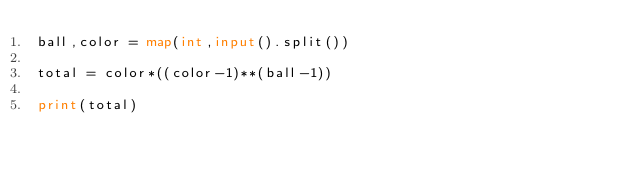<code> <loc_0><loc_0><loc_500><loc_500><_Python_>ball,color = map(int,input().split())

total = color*((color-1)**(ball-1))
               
print(total)</code> 